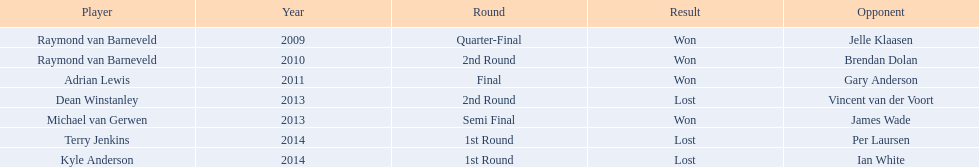Who are the players listed? Raymond van Barneveld, Raymond van Barneveld, Adrian Lewis, Dean Winstanley, Michael van Gerwen, Terry Jenkins, Kyle Anderson. Which of these players played in 2011? Adrian Lewis. Write the full table. {'header': ['Player', 'Year', 'Round', 'Result', 'Opponent'], 'rows': [['Raymond van Barneveld', '2009', 'Quarter-Final', 'Won', 'Jelle Klaasen'], ['Raymond van Barneveld', '2010', '2nd Round', 'Won', 'Brendan Dolan'], ['Adrian Lewis', '2011', 'Final', 'Won', 'Gary Anderson'], ['Dean Winstanley', '2013', '2nd Round', 'Lost', 'Vincent van der Voort'], ['Michael van Gerwen', '2013', 'Semi Final', 'Won', 'James Wade'], ['Terry Jenkins', '2014', '1st Round', 'Lost', 'Per Laursen'], ['Kyle Anderson', '2014', '1st Round', 'Lost', 'Ian White']]} 